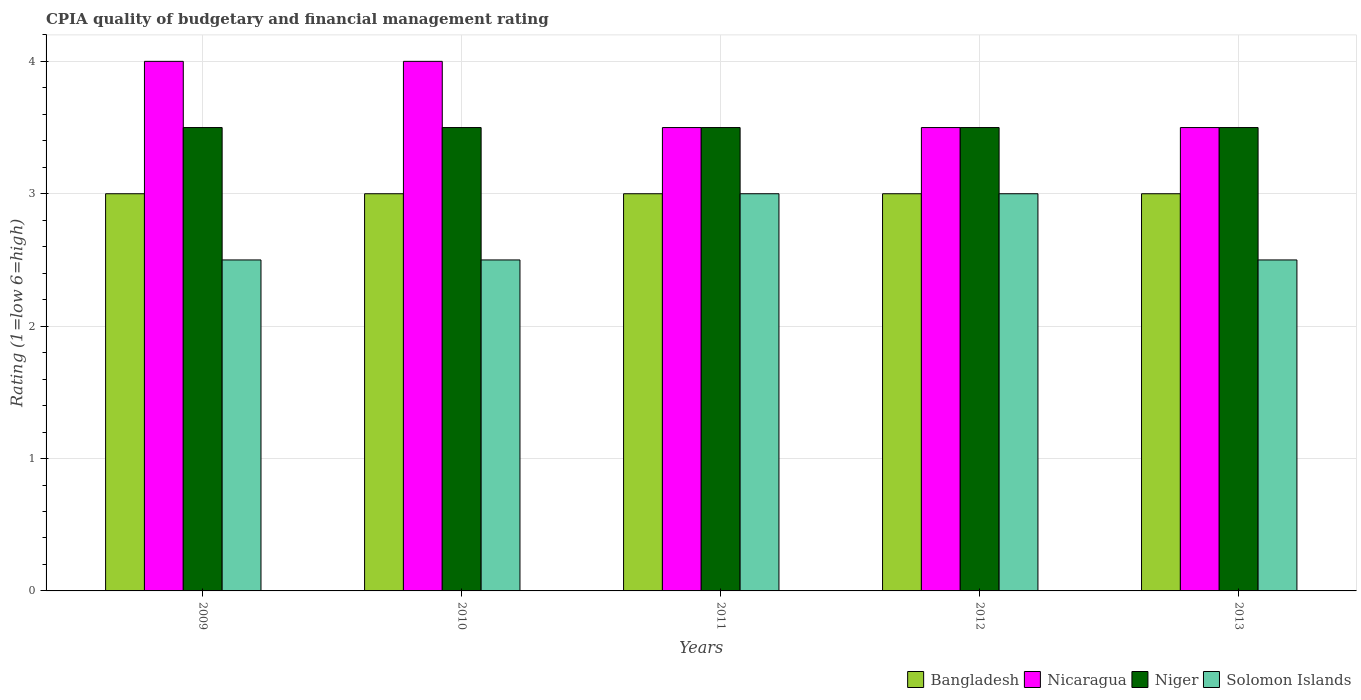Are the number of bars per tick equal to the number of legend labels?
Provide a succinct answer. Yes. Are the number of bars on each tick of the X-axis equal?
Your response must be concise. Yes. How many bars are there on the 4th tick from the left?
Your answer should be very brief. 4. Across all years, what is the maximum CPIA rating in Niger?
Offer a very short reply. 3.5. Across all years, what is the minimum CPIA rating in Bangladesh?
Make the answer very short. 3. In which year was the CPIA rating in Solomon Islands maximum?
Your answer should be very brief. 2011. In which year was the CPIA rating in Niger minimum?
Make the answer very short. 2009. What is the total CPIA rating in Nicaragua in the graph?
Offer a very short reply. 18.5. What is the average CPIA rating in Solomon Islands per year?
Provide a succinct answer. 2.7. In how many years, is the CPIA rating in Bangladesh greater than 0.6000000000000001?
Your response must be concise. 5. What is the difference between the highest and the second highest CPIA rating in Nicaragua?
Your answer should be very brief. 0. Is the sum of the CPIA rating in Solomon Islands in 2009 and 2012 greater than the maximum CPIA rating in Niger across all years?
Make the answer very short. Yes. What does the 4th bar from the left in 2012 represents?
Keep it short and to the point. Solomon Islands. What does the 4th bar from the right in 2012 represents?
Provide a short and direct response. Bangladesh. Are all the bars in the graph horizontal?
Offer a very short reply. No. Are the values on the major ticks of Y-axis written in scientific E-notation?
Provide a succinct answer. No. Does the graph contain grids?
Provide a succinct answer. Yes. How are the legend labels stacked?
Offer a very short reply. Horizontal. What is the title of the graph?
Make the answer very short. CPIA quality of budgetary and financial management rating. Does "Gabon" appear as one of the legend labels in the graph?
Give a very brief answer. No. What is the Rating (1=low 6=high) of Bangladesh in 2009?
Your answer should be compact. 3. What is the Rating (1=low 6=high) of Nicaragua in 2009?
Your response must be concise. 4. What is the Rating (1=low 6=high) in Niger in 2009?
Provide a short and direct response. 3.5. What is the Rating (1=low 6=high) in Bangladesh in 2010?
Your response must be concise. 3. What is the Rating (1=low 6=high) of Nicaragua in 2010?
Provide a short and direct response. 4. What is the Rating (1=low 6=high) of Niger in 2010?
Provide a short and direct response. 3.5. What is the Rating (1=low 6=high) of Solomon Islands in 2010?
Your response must be concise. 2.5. What is the Rating (1=low 6=high) in Bangladesh in 2011?
Offer a very short reply. 3. What is the Rating (1=low 6=high) in Niger in 2011?
Make the answer very short. 3.5. What is the Rating (1=low 6=high) of Solomon Islands in 2011?
Provide a short and direct response. 3. What is the Rating (1=low 6=high) of Bangladesh in 2012?
Offer a terse response. 3. What is the Rating (1=low 6=high) in Solomon Islands in 2013?
Keep it short and to the point. 2.5. Across all years, what is the maximum Rating (1=low 6=high) in Bangladesh?
Your answer should be very brief. 3. Across all years, what is the maximum Rating (1=low 6=high) of Nicaragua?
Give a very brief answer. 4. Across all years, what is the maximum Rating (1=low 6=high) of Solomon Islands?
Your response must be concise. 3. Across all years, what is the minimum Rating (1=low 6=high) in Bangladesh?
Give a very brief answer. 3. Across all years, what is the minimum Rating (1=low 6=high) of Solomon Islands?
Your response must be concise. 2.5. What is the total Rating (1=low 6=high) of Bangladesh in the graph?
Ensure brevity in your answer.  15. What is the total Rating (1=low 6=high) in Solomon Islands in the graph?
Provide a succinct answer. 13.5. What is the difference between the Rating (1=low 6=high) of Bangladesh in 2009 and that in 2010?
Offer a very short reply. 0. What is the difference between the Rating (1=low 6=high) of Nicaragua in 2009 and that in 2010?
Your answer should be compact. 0. What is the difference between the Rating (1=low 6=high) of Niger in 2009 and that in 2010?
Give a very brief answer. 0. What is the difference between the Rating (1=low 6=high) in Solomon Islands in 2009 and that in 2010?
Give a very brief answer. 0. What is the difference between the Rating (1=low 6=high) in Nicaragua in 2009 and that in 2011?
Your answer should be very brief. 0.5. What is the difference between the Rating (1=low 6=high) in Niger in 2009 and that in 2011?
Ensure brevity in your answer.  0. What is the difference between the Rating (1=low 6=high) in Bangladesh in 2009 and that in 2012?
Offer a very short reply. 0. What is the difference between the Rating (1=low 6=high) of Nicaragua in 2009 and that in 2012?
Give a very brief answer. 0.5. What is the difference between the Rating (1=low 6=high) of Niger in 2009 and that in 2012?
Keep it short and to the point. 0. What is the difference between the Rating (1=low 6=high) of Bangladesh in 2009 and that in 2013?
Offer a terse response. 0. What is the difference between the Rating (1=low 6=high) of Nicaragua in 2009 and that in 2013?
Provide a short and direct response. 0.5. What is the difference between the Rating (1=low 6=high) of Niger in 2009 and that in 2013?
Offer a terse response. 0. What is the difference between the Rating (1=low 6=high) of Solomon Islands in 2009 and that in 2013?
Keep it short and to the point. 0. What is the difference between the Rating (1=low 6=high) of Bangladesh in 2010 and that in 2011?
Provide a short and direct response. 0. What is the difference between the Rating (1=low 6=high) of Niger in 2010 and that in 2011?
Offer a terse response. 0. What is the difference between the Rating (1=low 6=high) in Solomon Islands in 2010 and that in 2011?
Give a very brief answer. -0.5. What is the difference between the Rating (1=low 6=high) in Solomon Islands in 2010 and that in 2012?
Your answer should be very brief. -0.5. What is the difference between the Rating (1=low 6=high) in Bangladesh in 2010 and that in 2013?
Offer a very short reply. 0. What is the difference between the Rating (1=low 6=high) in Nicaragua in 2010 and that in 2013?
Offer a very short reply. 0.5. What is the difference between the Rating (1=low 6=high) of Solomon Islands in 2010 and that in 2013?
Give a very brief answer. 0. What is the difference between the Rating (1=low 6=high) of Nicaragua in 2011 and that in 2012?
Your answer should be compact. 0. What is the difference between the Rating (1=low 6=high) in Niger in 2011 and that in 2012?
Provide a short and direct response. 0. What is the difference between the Rating (1=low 6=high) of Niger in 2011 and that in 2013?
Your response must be concise. 0. What is the difference between the Rating (1=low 6=high) of Bangladesh in 2012 and that in 2013?
Provide a succinct answer. 0. What is the difference between the Rating (1=low 6=high) of Nicaragua in 2012 and that in 2013?
Ensure brevity in your answer.  0. What is the difference between the Rating (1=low 6=high) in Niger in 2012 and that in 2013?
Make the answer very short. 0. What is the difference between the Rating (1=low 6=high) in Solomon Islands in 2012 and that in 2013?
Keep it short and to the point. 0.5. What is the difference between the Rating (1=low 6=high) of Bangladesh in 2009 and the Rating (1=low 6=high) of Nicaragua in 2010?
Provide a short and direct response. -1. What is the difference between the Rating (1=low 6=high) of Bangladesh in 2009 and the Rating (1=low 6=high) of Niger in 2010?
Give a very brief answer. -0.5. What is the difference between the Rating (1=low 6=high) of Bangladesh in 2009 and the Rating (1=low 6=high) of Solomon Islands in 2010?
Your response must be concise. 0.5. What is the difference between the Rating (1=low 6=high) of Nicaragua in 2009 and the Rating (1=low 6=high) of Solomon Islands in 2010?
Ensure brevity in your answer.  1.5. What is the difference between the Rating (1=low 6=high) in Bangladesh in 2009 and the Rating (1=low 6=high) in Nicaragua in 2011?
Your response must be concise. -0.5. What is the difference between the Rating (1=low 6=high) of Bangladesh in 2009 and the Rating (1=low 6=high) of Niger in 2011?
Offer a terse response. -0.5. What is the difference between the Rating (1=low 6=high) in Nicaragua in 2009 and the Rating (1=low 6=high) in Solomon Islands in 2011?
Give a very brief answer. 1. What is the difference between the Rating (1=low 6=high) in Niger in 2009 and the Rating (1=low 6=high) in Solomon Islands in 2011?
Your answer should be very brief. 0.5. What is the difference between the Rating (1=low 6=high) in Bangladesh in 2009 and the Rating (1=low 6=high) in Nicaragua in 2012?
Ensure brevity in your answer.  -0.5. What is the difference between the Rating (1=low 6=high) in Bangladesh in 2009 and the Rating (1=low 6=high) in Niger in 2012?
Make the answer very short. -0.5. What is the difference between the Rating (1=low 6=high) of Bangladesh in 2009 and the Rating (1=low 6=high) of Solomon Islands in 2012?
Your answer should be very brief. 0. What is the difference between the Rating (1=low 6=high) in Nicaragua in 2009 and the Rating (1=low 6=high) in Solomon Islands in 2012?
Provide a succinct answer. 1. What is the difference between the Rating (1=low 6=high) in Niger in 2009 and the Rating (1=low 6=high) in Solomon Islands in 2012?
Offer a very short reply. 0.5. What is the difference between the Rating (1=low 6=high) of Bangladesh in 2009 and the Rating (1=low 6=high) of Niger in 2013?
Make the answer very short. -0.5. What is the difference between the Rating (1=low 6=high) of Bangladesh in 2009 and the Rating (1=low 6=high) of Solomon Islands in 2013?
Your response must be concise. 0.5. What is the difference between the Rating (1=low 6=high) in Nicaragua in 2009 and the Rating (1=low 6=high) in Niger in 2013?
Your answer should be compact. 0.5. What is the difference between the Rating (1=low 6=high) in Nicaragua in 2009 and the Rating (1=low 6=high) in Solomon Islands in 2013?
Give a very brief answer. 1.5. What is the difference between the Rating (1=low 6=high) of Bangladesh in 2010 and the Rating (1=low 6=high) of Niger in 2011?
Provide a short and direct response. -0.5. What is the difference between the Rating (1=low 6=high) of Nicaragua in 2010 and the Rating (1=low 6=high) of Solomon Islands in 2011?
Make the answer very short. 1. What is the difference between the Rating (1=low 6=high) in Bangladesh in 2010 and the Rating (1=low 6=high) in Nicaragua in 2012?
Provide a succinct answer. -0.5. What is the difference between the Rating (1=low 6=high) of Bangladesh in 2010 and the Rating (1=low 6=high) of Niger in 2012?
Ensure brevity in your answer.  -0.5. What is the difference between the Rating (1=low 6=high) in Nicaragua in 2010 and the Rating (1=low 6=high) in Niger in 2012?
Offer a very short reply. 0.5. What is the difference between the Rating (1=low 6=high) of Niger in 2010 and the Rating (1=low 6=high) of Solomon Islands in 2012?
Make the answer very short. 0.5. What is the difference between the Rating (1=low 6=high) of Bangladesh in 2010 and the Rating (1=low 6=high) of Niger in 2013?
Provide a succinct answer. -0.5. What is the difference between the Rating (1=low 6=high) in Nicaragua in 2010 and the Rating (1=low 6=high) in Solomon Islands in 2013?
Provide a short and direct response. 1.5. What is the difference between the Rating (1=low 6=high) in Niger in 2010 and the Rating (1=low 6=high) in Solomon Islands in 2013?
Offer a terse response. 1. What is the difference between the Rating (1=low 6=high) of Bangladesh in 2011 and the Rating (1=low 6=high) of Nicaragua in 2012?
Offer a very short reply. -0.5. What is the difference between the Rating (1=low 6=high) of Bangladesh in 2011 and the Rating (1=low 6=high) of Niger in 2013?
Your answer should be very brief. -0.5. What is the difference between the Rating (1=low 6=high) of Bangladesh in 2011 and the Rating (1=low 6=high) of Solomon Islands in 2013?
Keep it short and to the point. 0.5. What is the difference between the Rating (1=low 6=high) of Bangladesh in 2012 and the Rating (1=low 6=high) of Nicaragua in 2013?
Ensure brevity in your answer.  -0.5. What is the difference between the Rating (1=low 6=high) of Bangladesh in 2012 and the Rating (1=low 6=high) of Solomon Islands in 2013?
Give a very brief answer. 0.5. What is the difference between the Rating (1=low 6=high) in Nicaragua in 2012 and the Rating (1=low 6=high) in Solomon Islands in 2013?
Your response must be concise. 1. What is the average Rating (1=low 6=high) of Niger per year?
Offer a terse response. 3.5. What is the average Rating (1=low 6=high) of Solomon Islands per year?
Your answer should be very brief. 2.7. In the year 2009, what is the difference between the Rating (1=low 6=high) in Bangladesh and Rating (1=low 6=high) in Niger?
Ensure brevity in your answer.  -0.5. In the year 2009, what is the difference between the Rating (1=low 6=high) in Niger and Rating (1=low 6=high) in Solomon Islands?
Offer a very short reply. 1. In the year 2010, what is the difference between the Rating (1=low 6=high) in Bangladesh and Rating (1=low 6=high) in Niger?
Offer a very short reply. -0.5. In the year 2010, what is the difference between the Rating (1=low 6=high) in Nicaragua and Rating (1=low 6=high) in Niger?
Provide a short and direct response. 0.5. In the year 2010, what is the difference between the Rating (1=low 6=high) in Niger and Rating (1=low 6=high) in Solomon Islands?
Give a very brief answer. 1. In the year 2011, what is the difference between the Rating (1=low 6=high) in Nicaragua and Rating (1=low 6=high) in Solomon Islands?
Make the answer very short. 0.5. In the year 2012, what is the difference between the Rating (1=low 6=high) in Bangladesh and Rating (1=low 6=high) in Nicaragua?
Ensure brevity in your answer.  -0.5. In the year 2012, what is the difference between the Rating (1=low 6=high) in Bangladesh and Rating (1=low 6=high) in Niger?
Your answer should be compact. -0.5. In the year 2012, what is the difference between the Rating (1=low 6=high) in Niger and Rating (1=low 6=high) in Solomon Islands?
Your answer should be very brief. 0.5. In the year 2013, what is the difference between the Rating (1=low 6=high) in Bangladesh and Rating (1=low 6=high) in Nicaragua?
Give a very brief answer. -0.5. In the year 2013, what is the difference between the Rating (1=low 6=high) in Bangladesh and Rating (1=low 6=high) in Solomon Islands?
Your answer should be very brief. 0.5. In the year 2013, what is the difference between the Rating (1=low 6=high) of Nicaragua and Rating (1=low 6=high) of Niger?
Ensure brevity in your answer.  0. What is the ratio of the Rating (1=low 6=high) of Bangladesh in 2009 to that in 2010?
Ensure brevity in your answer.  1. What is the ratio of the Rating (1=low 6=high) of Nicaragua in 2009 to that in 2010?
Provide a succinct answer. 1. What is the ratio of the Rating (1=low 6=high) in Niger in 2009 to that in 2010?
Provide a succinct answer. 1. What is the ratio of the Rating (1=low 6=high) of Solomon Islands in 2009 to that in 2010?
Offer a very short reply. 1. What is the ratio of the Rating (1=low 6=high) of Nicaragua in 2009 to that in 2011?
Give a very brief answer. 1.14. What is the ratio of the Rating (1=low 6=high) of Solomon Islands in 2009 to that in 2011?
Your response must be concise. 0.83. What is the ratio of the Rating (1=low 6=high) in Solomon Islands in 2009 to that in 2012?
Your response must be concise. 0.83. What is the ratio of the Rating (1=low 6=high) in Nicaragua in 2009 to that in 2013?
Offer a terse response. 1.14. What is the ratio of the Rating (1=low 6=high) of Bangladesh in 2010 to that in 2011?
Make the answer very short. 1. What is the ratio of the Rating (1=low 6=high) in Nicaragua in 2010 to that in 2011?
Make the answer very short. 1.14. What is the ratio of the Rating (1=low 6=high) of Solomon Islands in 2010 to that in 2011?
Ensure brevity in your answer.  0.83. What is the ratio of the Rating (1=low 6=high) of Bangladesh in 2010 to that in 2012?
Offer a very short reply. 1. What is the ratio of the Rating (1=low 6=high) in Niger in 2010 to that in 2012?
Give a very brief answer. 1. What is the ratio of the Rating (1=low 6=high) of Solomon Islands in 2010 to that in 2012?
Offer a terse response. 0.83. What is the ratio of the Rating (1=low 6=high) of Nicaragua in 2010 to that in 2013?
Ensure brevity in your answer.  1.14. What is the ratio of the Rating (1=low 6=high) of Solomon Islands in 2010 to that in 2013?
Your answer should be very brief. 1. What is the ratio of the Rating (1=low 6=high) in Bangladesh in 2011 to that in 2012?
Give a very brief answer. 1. What is the ratio of the Rating (1=low 6=high) in Nicaragua in 2011 to that in 2012?
Your answer should be very brief. 1. What is the ratio of the Rating (1=low 6=high) of Niger in 2011 to that in 2012?
Offer a terse response. 1. What is the ratio of the Rating (1=low 6=high) of Bangladesh in 2011 to that in 2013?
Your response must be concise. 1. What is the ratio of the Rating (1=low 6=high) of Nicaragua in 2011 to that in 2013?
Provide a succinct answer. 1. What is the ratio of the Rating (1=low 6=high) of Niger in 2011 to that in 2013?
Make the answer very short. 1. What is the ratio of the Rating (1=low 6=high) in Bangladesh in 2012 to that in 2013?
Your answer should be very brief. 1. What is the ratio of the Rating (1=low 6=high) in Nicaragua in 2012 to that in 2013?
Offer a terse response. 1. What is the ratio of the Rating (1=low 6=high) of Niger in 2012 to that in 2013?
Give a very brief answer. 1. What is the ratio of the Rating (1=low 6=high) in Solomon Islands in 2012 to that in 2013?
Provide a succinct answer. 1.2. What is the difference between the highest and the second highest Rating (1=low 6=high) in Nicaragua?
Keep it short and to the point. 0. What is the difference between the highest and the second highest Rating (1=low 6=high) of Niger?
Make the answer very short. 0. What is the difference between the highest and the lowest Rating (1=low 6=high) in Bangladesh?
Your answer should be very brief. 0. What is the difference between the highest and the lowest Rating (1=low 6=high) in Nicaragua?
Ensure brevity in your answer.  0.5. 